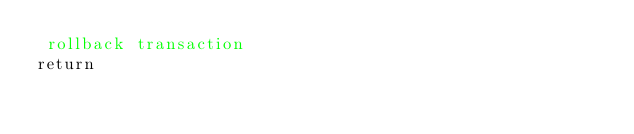Convert code to text. <code><loc_0><loc_0><loc_500><loc_500><_SQL_> rollback transaction
return
</code> 